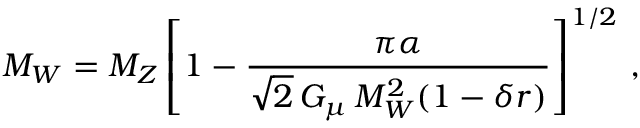Convert formula to latex. <formula><loc_0><loc_0><loc_500><loc_500>M _ { W } = M _ { Z } \left [ 1 - { \frac { \pi \alpha } { \sqrt { 2 } \, G _ { \mu } \, M _ { W } ^ { 2 } ( 1 - \delta r ) } } \right ] ^ { 1 / 2 } \, ,</formula> 